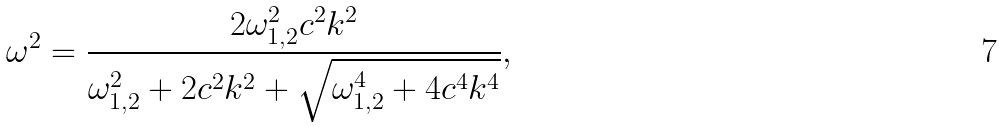Convert formula to latex. <formula><loc_0><loc_0><loc_500><loc_500>\omega ^ { 2 } = \frac { 2 \omega _ { 1 , 2 } ^ { 2 } c ^ { 2 } k ^ { 2 } } { \omega _ { 1 , 2 } ^ { 2 } + 2 c ^ { 2 } k ^ { 2 } + \sqrt { \omega _ { 1 , 2 } ^ { 4 } + 4 c ^ { 4 } k ^ { 4 } } } ,</formula> 